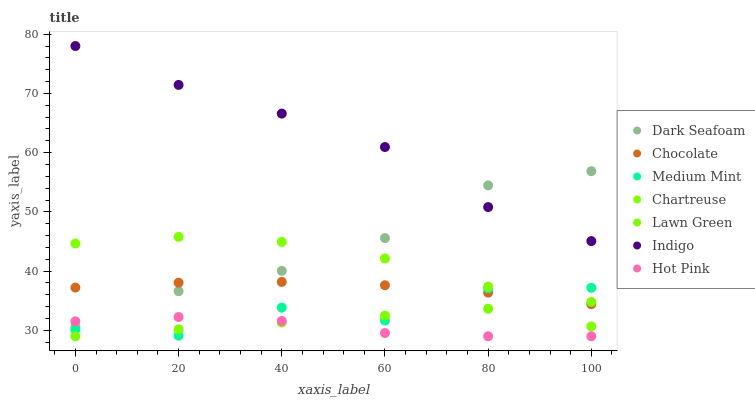Does Hot Pink have the minimum area under the curve?
Answer yes or no. Yes. Does Indigo have the maximum area under the curve?
Answer yes or no. Yes. Does Lawn Green have the minimum area under the curve?
Answer yes or no. No. Does Lawn Green have the maximum area under the curve?
Answer yes or no. No. Is Lawn Green the smoothest?
Answer yes or no. Yes. Is Medium Mint the roughest?
Answer yes or no. Yes. Is Indigo the smoothest?
Answer yes or no. No. Is Indigo the roughest?
Answer yes or no. No. Does Lawn Green have the lowest value?
Answer yes or no. Yes. Does Indigo have the lowest value?
Answer yes or no. No. Does Indigo have the highest value?
Answer yes or no. Yes. Does Lawn Green have the highest value?
Answer yes or no. No. Is Hot Pink less than Indigo?
Answer yes or no. Yes. Is Indigo greater than Chocolate?
Answer yes or no. Yes. Does Hot Pink intersect Medium Mint?
Answer yes or no. Yes. Is Hot Pink less than Medium Mint?
Answer yes or no. No. Is Hot Pink greater than Medium Mint?
Answer yes or no. No. Does Hot Pink intersect Indigo?
Answer yes or no. No. 